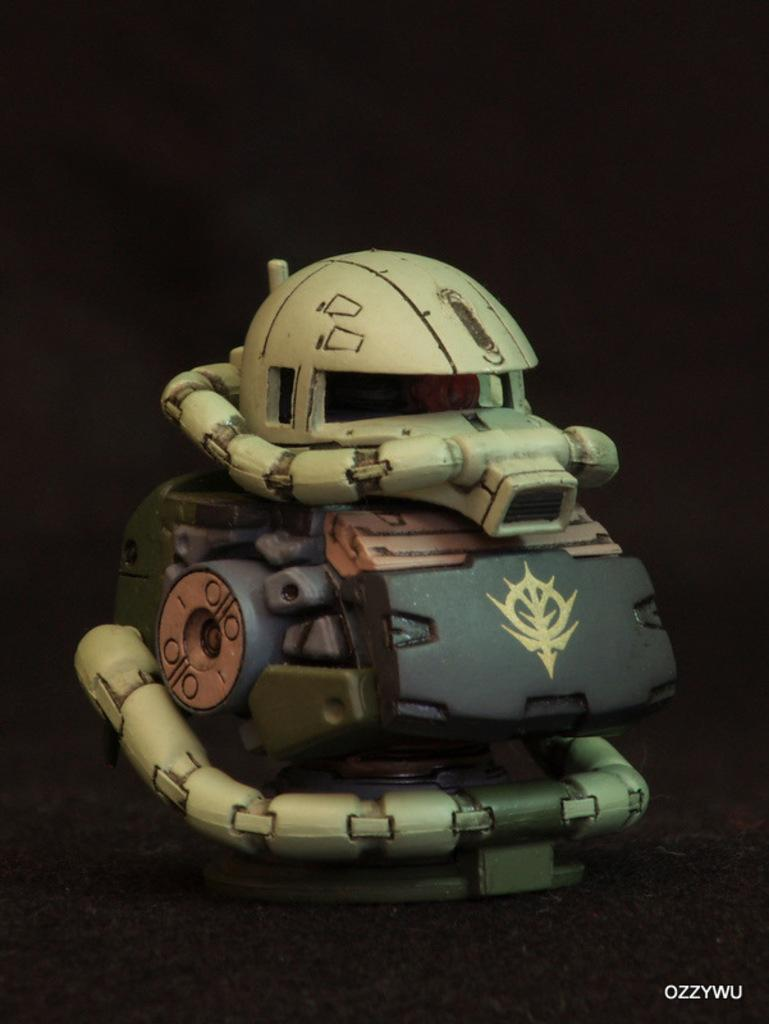What object is placed on a surface in the image? There is a toy placed on a surface in the image. Where can the text be found in the image? The text is written at the right bottom of the image. How would you describe the overall lighting in the image? The backdrop of the image is dark. What reward does the sister receive for her belief in the image? There is no sister or belief present in the image; it only features a toy placed on a surface and text at the right bottom. 